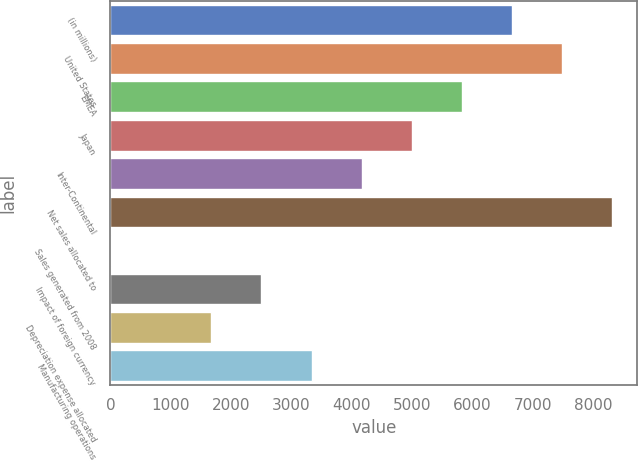Convert chart to OTSL. <chart><loc_0><loc_0><loc_500><loc_500><bar_chart><fcel>(in millions)<fcel>United States<fcel>EMEA<fcel>Japan<fcel>Inter-Continental<fcel>Net sales allocated to<fcel>Sales generated from 2008<fcel>Impact of foreign currency<fcel>Depreciation expense allocated<fcel>Manufacturing operations<nl><fcel>6658.2<fcel>7489.1<fcel>5827.3<fcel>4996.4<fcel>4165.5<fcel>8320<fcel>11<fcel>2503.7<fcel>1672.8<fcel>3334.6<nl></chart> 